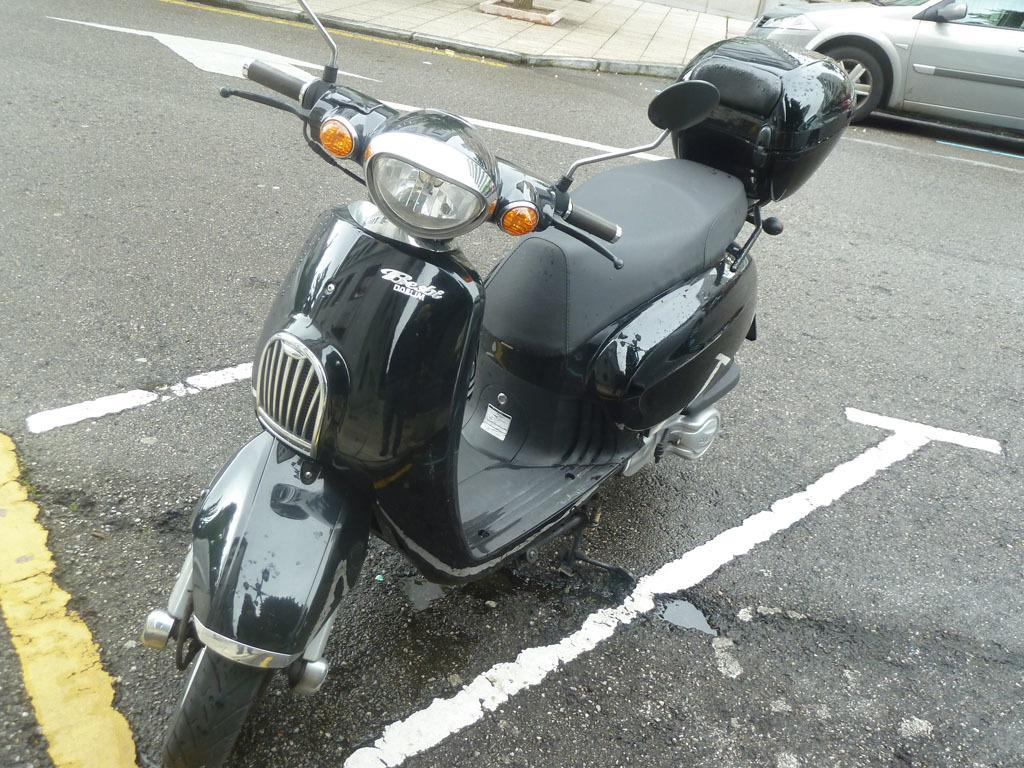What type of vehicle is in the front of the image? There is a black color scooter in the front of the image. Where is the car located in the image? The car is at the right top of the image. What can be seen at the bottom of the image? There is a road visible at the bottom of the image. Where is the key to the drawer in the image? There is no key or drawer present in the image. What type of amusement can be seen in the image? There is no amusement depicted in the image; it features a scooter, a car, and a road. 